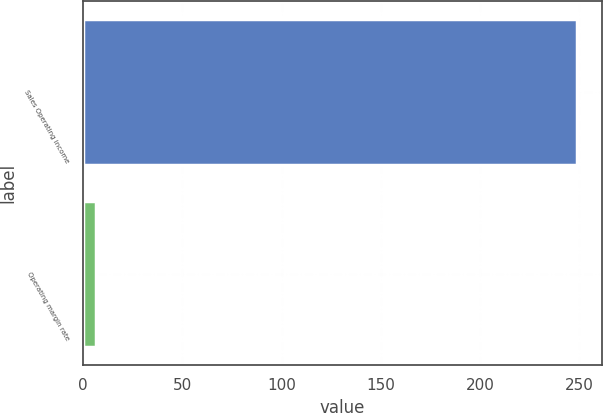<chart> <loc_0><loc_0><loc_500><loc_500><bar_chart><fcel>Sales Operating income<fcel>Operating margin rate<nl><fcel>249<fcel>6.7<nl></chart> 